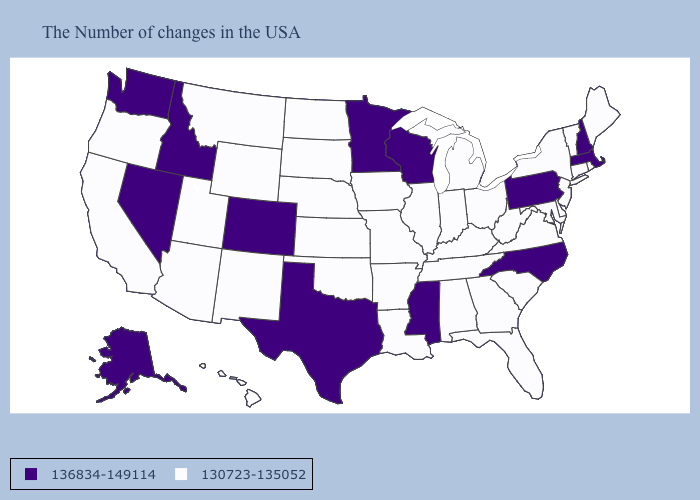What is the value of Illinois?
Answer briefly. 130723-135052. What is the value of Arkansas?
Write a very short answer. 130723-135052. What is the highest value in the West ?
Give a very brief answer. 136834-149114. Does the map have missing data?
Give a very brief answer. No. What is the highest value in the MidWest ?
Short answer required. 136834-149114. What is the highest value in the West ?
Quick response, please. 136834-149114. Does Arkansas have the same value as Montana?
Give a very brief answer. Yes. What is the value of Wyoming?
Keep it brief. 130723-135052. Does Nevada have the same value as Nebraska?
Short answer required. No. Name the states that have a value in the range 136834-149114?
Quick response, please. Massachusetts, New Hampshire, Pennsylvania, North Carolina, Wisconsin, Mississippi, Minnesota, Texas, Colorado, Idaho, Nevada, Washington, Alaska. Does Louisiana have a lower value than New Jersey?
Answer briefly. No. Name the states that have a value in the range 130723-135052?
Quick response, please. Maine, Rhode Island, Vermont, Connecticut, New York, New Jersey, Delaware, Maryland, Virginia, South Carolina, West Virginia, Ohio, Florida, Georgia, Michigan, Kentucky, Indiana, Alabama, Tennessee, Illinois, Louisiana, Missouri, Arkansas, Iowa, Kansas, Nebraska, Oklahoma, South Dakota, North Dakota, Wyoming, New Mexico, Utah, Montana, Arizona, California, Oregon, Hawaii. Name the states that have a value in the range 136834-149114?
Answer briefly. Massachusetts, New Hampshire, Pennsylvania, North Carolina, Wisconsin, Mississippi, Minnesota, Texas, Colorado, Idaho, Nevada, Washington, Alaska. What is the highest value in states that border Michigan?
Concise answer only. 136834-149114. 